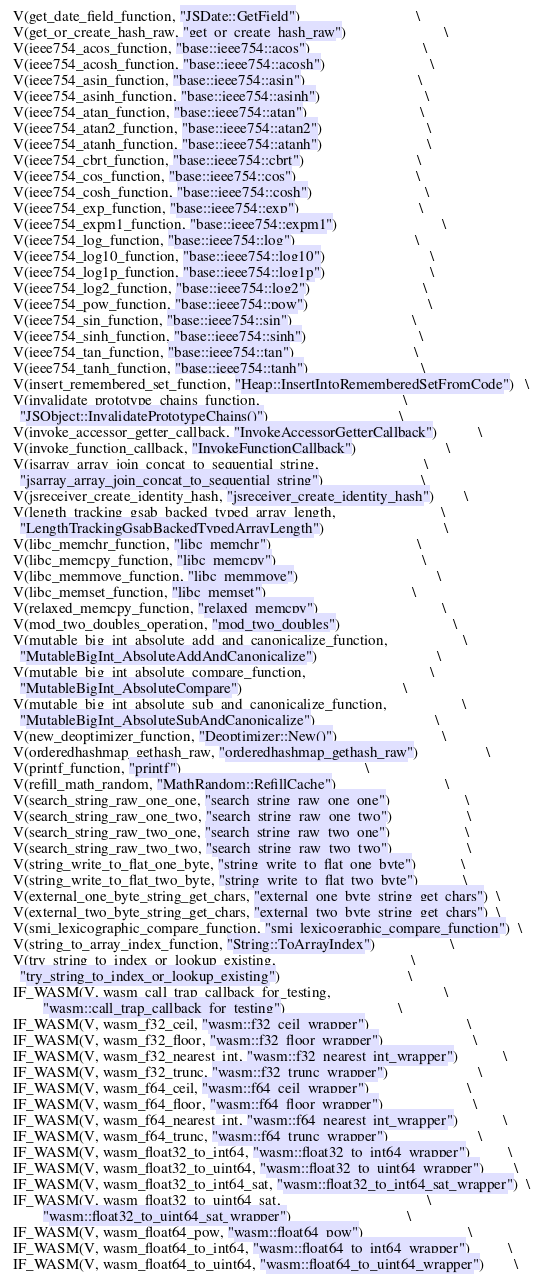<code> <loc_0><loc_0><loc_500><loc_500><_C_>  V(get_date_field_function, "JSDate::GetField")                               \
  V(get_or_create_hash_raw, "get_or_create_hash_raw")                          \
  V(ieee754_acos_function, "base::ieee754::acos")                              \
  V(ieee754_acosh_function, "base::ieee754::acosh")                            \
  V(ieee754_asin_function, "base::ieee754::asin")                              \
  V(ieee754_asinh_function, "base::ieee754::asinh")                            \
  V(ieee754_atan_function, "base::ieee754::atan")                              \
  V(ieee754_atan2_function, "base::ieee754::atan2")                            \
  V(ieee754_atanh_function, "base::ieee754::atanh")                            \
  V(ieee754_cbrt_function, "base::ieee754::cbrt")                              \
  V(ieee754_cos_function, "base::ieee754::cos")                                \
  V(ieee754_cosh_function, "base::ieee754::cosh")                              \
  V(ieee754_exp_function, "base::ieee754::exp")                                \
  V(ieee754_expm1_function, "base::ieee754::expm1")                            \
  V(ieee754_log_function, "base::ieee754::log")                                \
  V(ieee754_log10_function, "base::ieee754::log10")                            \
  V(ieee754_log1p_function, "base::ieee754::log1p")                            \
  V(ieee754_log2_function, "base::ieee754::log2")                              \
  V(ieee754_pow_function, "base::ieee754::pow")                                \
  V(ieee754_sin_function, "base::ieee754::sin")                                \
  V(ieee754_sinh_function, "base::ieee754::sinh")                              \
  V(ieee754_tan_function, "base::ieee754::tan")                                \
  V(ieee754_tanh_function, "base::ieee754::tanh")                              \
  V(insert_remembered_set_function, "Heap::InsertIntoRememberedSetFromCode")   \
  V(invalidate_prototype_chains_function,                                      \
    "JSObject::InvalidatePrototypeChains()")                                   \
  V(invoke_accessor_getter_callback, "InvokeAccessorGetterCallback")           \
  V(invoke_function_callback, "InvokeFunctionCallback")                        \
  V(jsarray_array_join_concat_to_sequential_string,                            \
    "jsarray_array_join_concat_to_sequential_string")                          \
  V(jsreceiver_create_identity_hash, "jsreceiver_create_identity_hash")        \
  V(length_tracking_gsab_backed_typed_array_length,                            \
    "LengthTrackingGsabBackedTypedArrayLength")                                \
  V(libc_memchr_function, "libc_memchr")                                       \
  V(libc_memcpy_function, "libc_memcpy")                                       \
  V(libc_memmove_function, "libc_memmove")                                     \
  V(libc_memset_function, "libc_memset")                                       \
  V(relaxed_memcpy_function, "relaxed_memcpy")                                 \
  V(mod_two_doubles_operation, "mod_two_doubles")                              \
  V(mutable_big_int_absolute_add_and_canonicalize_function,                    \
    "MutableBigInt_AbsoluteAddAndCanonicalize")                                \
  V(mutable_big_int_absolute_compare_function,                                 \
    "MutableBigInt_AbsoluteCompare")                                           \
  V(mutable_big_int_absolute_sub_and_canonicalize_function,                    \
    "MutableBigInt_AbsoluteSubAndCanonicalize")                                \
  V(new_deoptimizer_function, "Deoptimizer::New()")                            \
  V(orderedhashmap_gethash_raw, "orderedhashmap_gethash_raw")                  \
  V(printf_function, "printf")                                                 \
  V(refill_math_random, "MathRandom::RefillCache")                             \
  V(search_string_raw_one_one, "search_string_raw_one_one")                    \
  V(search_string_raw_one_two, "search_string_raw_one_two")                    \
  V(search_string_raw_two_one, "search_string_raw_two_one")                    \
  V(search_string_raw_two_two, "search_string_raw_two_two")                    \
  V(string_write_to_flat_one_byte, "string_write_to_flat_one_byte")            \
  V(string_write_to_flat_two_byte, "string_write_to_flat_two_byte")            \
  V(external_one_byte_string_get_chars, "external_one_byte_string_get_chars")  \
  V(external_two_byte_string_get_chars, "external_two_byte_string_get_chars")  \
  V(smi_lexicographic_compare_function, "smi_lexicographic_compare_function")  \
  V(string_to_array_index_function, "String::ToArrayIndex")                    \
  V(try_string_to_index_or_lookup_existing,                                    \
    "try_string_to_index_or_lookup_existing")                                  \
  IF_WASM(V, wasm_call_trap_callback_for_testing,                              \
          "wasm::call_trap_callback_for_testing")                              \
  IF_WASM(V, wasm_f32_ceil, "wasm::f32_ceil_wrapper")                          \
  IF_WASM(V, wasm_f32_floor, "wasm::f32_floor_wrapper")                        \
  IF_WASM(V, wasm_f32_nearest_int, "wasm::f32_nearest_int_wrapper")            \
  IF_WASM(V, wasm_f32_trunc, "wasm::f32_trunc_wrapper")                        \
  IF_WASM(V, wasm_f64_ceil, "wasm::f64_ceil_wrapper")                          \
  IF_WASM(V, wasm_f64_floor, "wasm::f64_floor_wrapper")                        \
  IF_WASM(V, wasm_f64_nearest_int, "wasm::f64_nearest_int_wrapper")            \
  IF_WASM(V, wasm_f64_trunc, "wasm::f64_trunc_wrapper")                        \
  IF_WASM(V, wasm_float32_to_int64, "wasm::float32_to_int64_wrapper")          \
  IF_WASM(V, wasm_float32_to_uint64, "wasm::float32_to_uint64_wrapper")        \
  IF_WASM(V, wasm_float32_to_int64_sat, "wasm::float32_to_int64_sat_wrapper")  \
  IF_WASM(V, wasm_float32_to_uint64_sat,                                       \
          "wasm::float32_to_uint64_sat_wrapper")                               \
  IF_WASM(V, wasm_float64_pow, "wasm::float64_pow")                            \
  IF_WASM(V, wasm_float64_to_int64, "wasm::float64_to_int64_wrapper")          \
  IF_WASM(V, wasm_float64_to_uint64, "wasm::float64_to_uint64_wrapper")        \</code> 